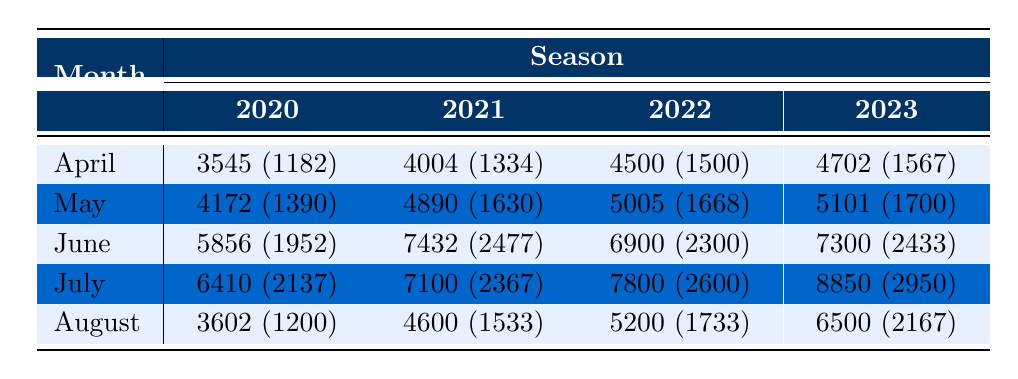What was the total attendance in June 2022? The total attendance for June 2022 is listed in the table as 6900.
Answer: 6900 In which month in 2021 was the average attendance the highest? The average attendance values for each month in 2021 are 1334 (April), 1630 (May), 2477 (June), 2367 (July), and 1533 (August). June has the highest average attendance of 2477.
Answer: June What is the total attendance for home games in July across all four seasons? The total attendance in July for each season is: 6410 (2020), 7100 (2021), 7800 (2022), and 8850 (2023). Adding these gives: 6410 + 7100 + 7800 + 8850 = 30260.
Answer: 30260 Did the attendance in April 2021 exceed that of April 2020? The attendance for April 2021 is 4004, while for April 2020 it is 3545. Since 4004 > 3545, the statement is true.
Answer: Yes What was the average attendance increase from July 2022 to July 2023? The average attendance in July 2022 is 2600 and in July 2023 it is 2950. The increase is calculated as: 2950 - 2600 = 350.
Answer: 350 Which season had the highest total attendance in August? The total attendances for August across the seasons are: 3602 (2020), 4600 (2021), 5200 (2022), and 6500 (2023). August 2023 had the highest total attendance of 6500.
Answer: 2023 How many months had an average attendance of over 2000 in 2022? In 2022, the average attendances in April, May, June, July, and August are 1500, 1668, 2300, 2600, and 1733 respectively. Only June and July had averages over 2000. Counting those gives a total of 2 months.
Answer: 2 What is the total attendance from April to August for each season, and which season had the highest total overall? The total attendance for each season is as follows: 2020: 3545 + 4172 + 5856 + 6410 + 3602 = 21085; 2021: 4004 + 4890 + 7432 + 7100 + 4600 = 28026; 2022: 4500 + 5005 + 6900 + 7800 + 5200 = 29905; 2023: 4702 + 5101 + 7300 + 8850 + 6500 = 33653. Hence, 2023 had the highest total attendance of 33653.
Answer: 2023 Was the average attendance in June 2023 greater than the average attendance in June 2021? The average attendance in June 2023 is 2433, while in June 2021 it is 2477. Since 2433 < 2477, the statement is false.
Answer: No What is the average attendance across all months for the 2021 season? The average attendance for 2021 can be calculated by averaging: (1334 + 1630 + 2477 + 2367 + 1533) / 5 = 1878.2.
Answer: 1878.2 